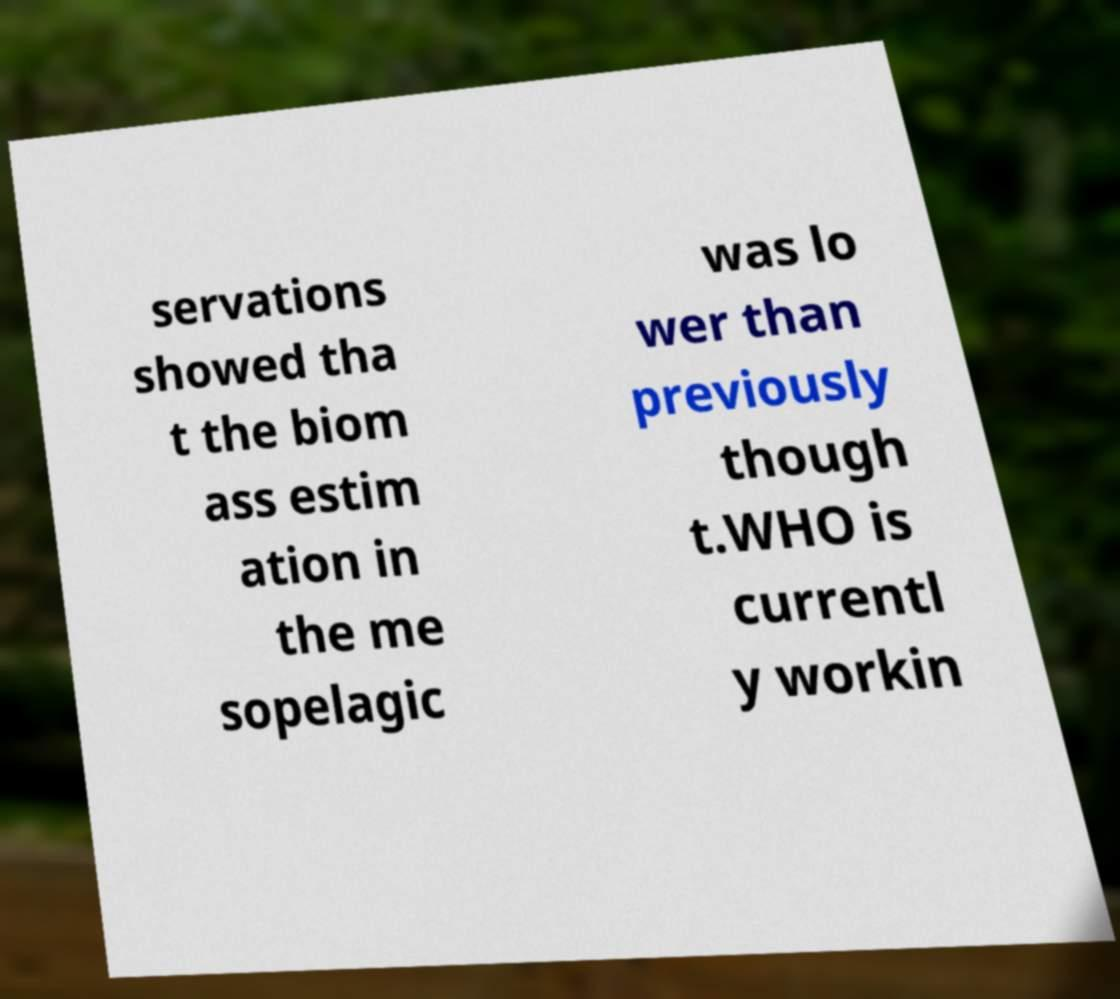I need the written content from this picture converted into text. Can you do that? servations showed tha t the biom ass estim ation in the me sopelagic was lo wer than previously though t.WHO is currentl y workin 